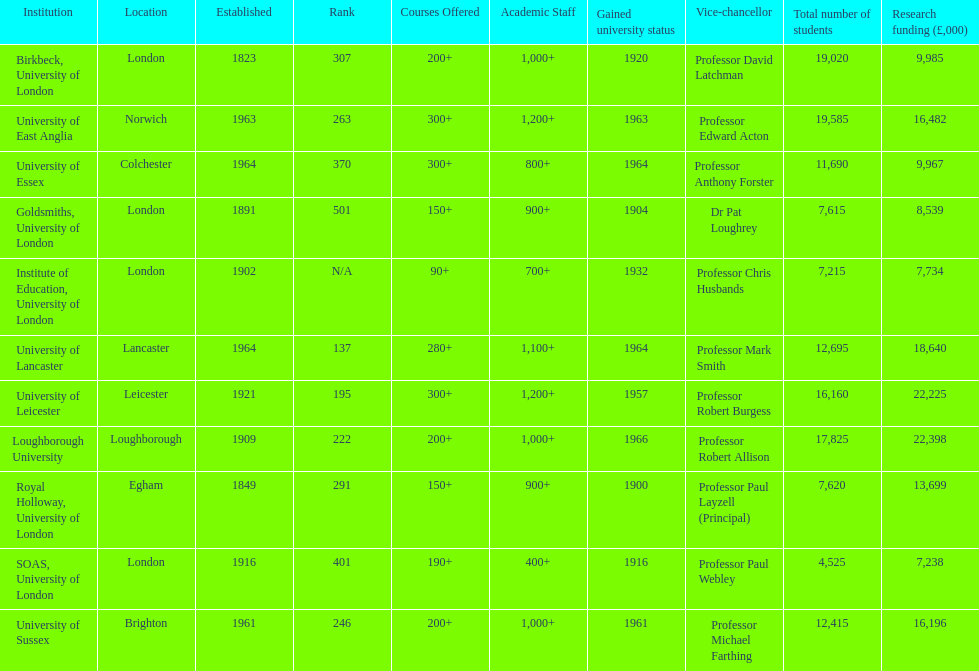What is the most recent institution to gain university status? Loughborough University. 